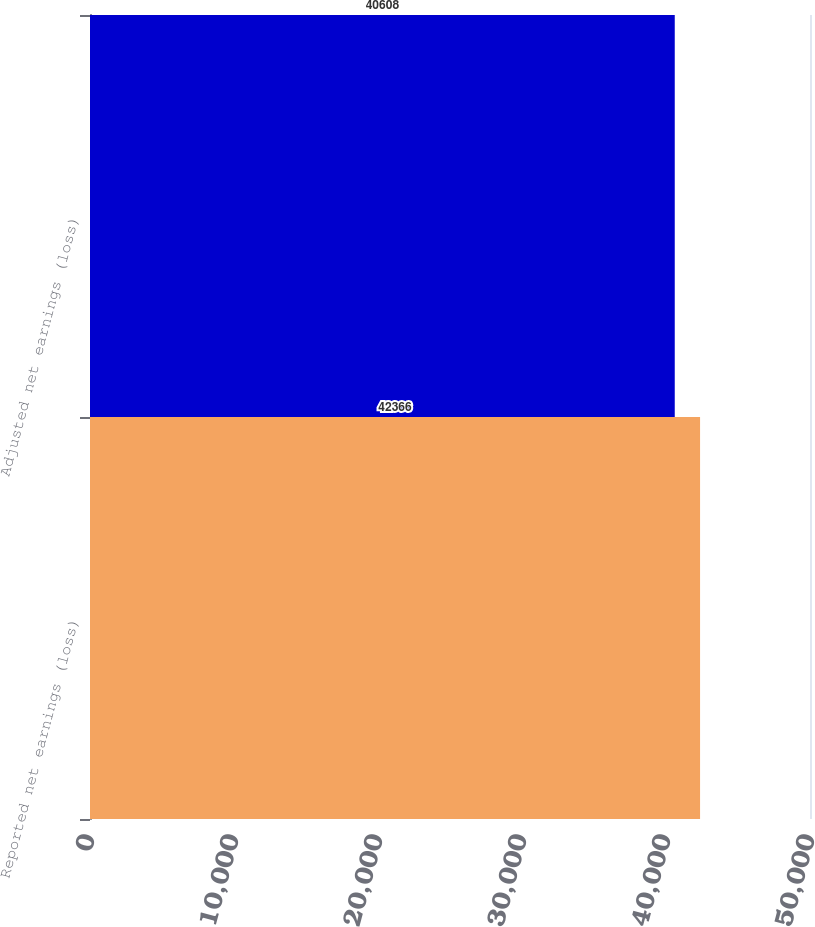Convert chart. <chart><loc_0><loc_0><loc_500><loc_500><bar_chart><fcel>Reported net earnings (loss)<fcel>Adjusted net earnings (loss)<nl><fcel>42366<fcel>40608<nl></chart> 